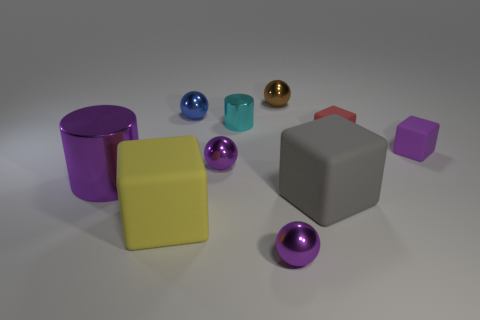Is the color of the metallic cylinder that is to the right of the small blue object the same as the cylinder that is to the left of the tiny cyan shiny cylinder?
Keep it short and to the point. No. What is the shape of the small matte object left of the tiny purple cube?
Keep it short and to the point. Cube. What color is the tiny cylinder?
Ensure brevity in your answer.  Cyan. There is a red thing that is the same material as the gray cube; what shape is it?
Ensure brevity in your answer.  Cube. Does the block to the left of the brown thing have the same size as the big gray matte object?
Offer a very short reply. Yes. What number of things are large things left of the gray object or large rubber blocks to the right of the big yellow block?
Your response must be concise. 3. There is a shiny ball in front of the large yellow object; is its color the same as the tiny metallic cylinder?
Your answer should be very brief. No. How many metallic things are tiny purple blocks or large yellow cubes?
Your response must be concise. 0. What is the shape of the large metal object?
Provide a short and direct response. Cylinder. Is there anything else that is the same material as the tiny red object?
Provide a succinct answer. Yes. 